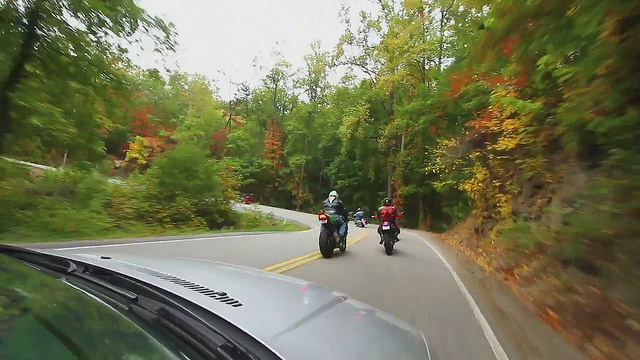Describe the objects in this image and their specific colors. I can see car in lightgray, darkgray, black, and darkgreen tones, motorcycle in lightgray, black, gray, maroon, and darkgreen tones, people in lightgray, black, gray, darkgray, and ivory tones, people in lightgray, black, maroon, brown, and gray tones, and motorcycle in lightgray, black, and gray tones in this image. 